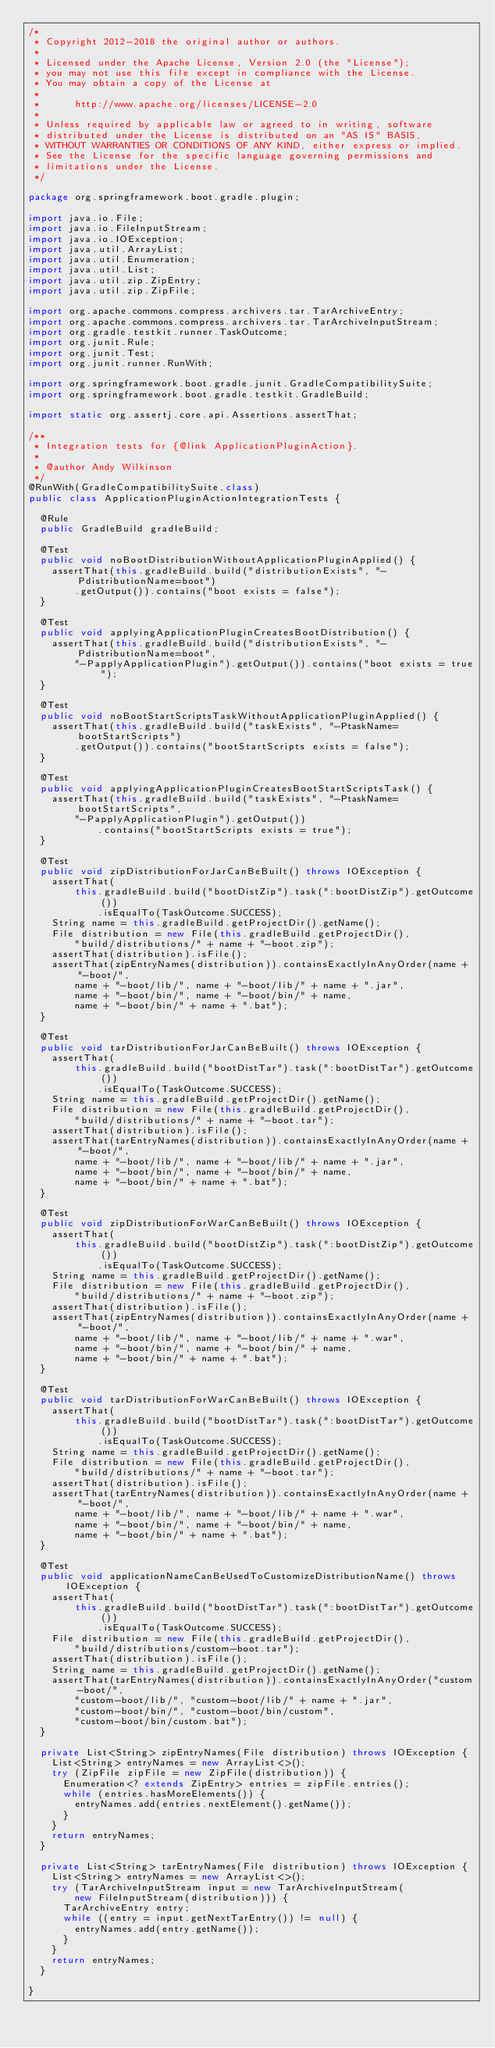Convert code to text. <code><loc_0><loc_0><loc_500><loc_500><_Java_>/*
 * Copyright 2012-2018 the original author or authors.
 *
 * Licensed under the Apache License, Version 2.0 (the "License");
 * you may not use this file except in compliance with the License.
 * You may obtain a copy of the License at
 *
 *      http://www.apache.org/licenses/LICENSE-2.0
 *
 * Unless required by applicable law or agreed to in writing, software
 * distributed under the License is distributed on an "AS IS" BASIS,
 * WITHOUT WARRANTIES OR CONDITIONS OF ANY KIND, either express or implied.
 * See the License for the specific language governing permissions and
 * limitations under the License.
 */

package org.springframework.boot.gradle.plugin;

import java.io.File;
import java.io.FileInputStream;
import java.io.IOException;
import java.util.ArrayList;
import java.util.Enumeration;
import java.util.List;
import java.util.zip.ZipEntry;
import java.util.zip.ZipFile;

import org.apache.commons.compress.archivers.tar.TarArchiveEntry;
import org.apache.commons.compress.archivers.tar.TarArchiveInputStream;
import org.gradle.testkit.runner.TaskOutcome;
import org.junit.Rule;
import org.junit.Test;
import org.junit.runner.RunWith;

import org.springframework.boot.gradle.junit.GradleCompatibilitySuite;
import org.springframework.boot.gradle.testkit.GradleBuild;

import static org.assertj.core.api.Assertions.assertThat;

/**
 * Integration tests for {@link ApplicationPluginAction}.
 *
 * @author Andy Wilkinson
 */
@RunWith(GradleCompatibilitySuite.class)
public class ApplicationPluginActionIntegrationTests {

	@Rule
	public GradleBuild gradleBuild;

	@Test
	public void noBootDistributionWithoutApplicationPluginApplied() {
		assertThat(this.gradleBuild.build("distributionExists", "-PdistributionName=boot")
				.getOutput()).contains("boot exists = false");
	}

	@Test
	public void applyingApplicationPluginCreatesBootDistribution() {
		assertThat(this.gradleBuild.build("distributionExists", "-PdistributionName=boot",
				"-PapplyApplicationPlugin").getOutput()).contains("boot exists = true");
	}

	@Test
	public void noBootStartScriptsTaskWithoutApplicationPluginApplied() {
		assertThat(this.gradleBuild.build("taskExists", "-PtaskName=bootStartScripts")
				.getOutput()).contains("bootStartScripts exists = false");
	}

	@Test
	public void applyingApplicationPluginCreatesBootStartScriptsTask() {
		assertThat(this.gradleBuild.build("taskExists", "-PtaskName=bootStartScripts",
				"-PapplyApplicationPlugin").getOutput())
						.contains("bootStartScripts exists = true");
	}

	@Test
	public void zipDistributionForJarCanBeBuilt() throws IOException {
		assertThat(
				this.gradleBuild.build("bootDistZip").task(":bootDistZip").getOutcome())
						.isEqualTo(TaskOutcome.SUCCESS);
		String name = this.gradleBuild.getProjectDir().getName();
		File distribution = new File(this.gradleBuild.getProjectDir(),
				"build/distributions/" + name + "-boot.zip");
		assertThat(distribution).isFile();
		assertThat(zipEntryNames(distribution)).containsExactlyInAnyOrder(name + "-boot/",
				name + "-boot/lib/", name + "-boot/lib/" + name + ".jar",
				name + "-boot/bin/", name + "-boot/bin/" + name,
				name + "-boot/bin/" + name + ".bat");
	}

	@Test
	public void tarDistributionForJarCanBeBuilt() throws IOException {
		assertThat(
				this.gradleBuild.build("bootDistTar").task(":bootDistTar").getOutcome())
						.isEqualTo(TaskOutcome.SUCCESS);
		String name = this.gradleBuild.getProjectDir().getName();
		File distribution = new File(this.gradleBuild.getProjectDir(),
				"build/distributions/" + name + "-boot.tar");
		assertThat(distribution).isFile();
		assertThat(tarEntryNames(distribution)).containsExactlyInAnyOrder(name + "-boot/",
				name + "-boot/lib/", name + "-boot/lib/" + name + ".jar",
				name + "-boot/bin/", name + "-boot/bin/" + name,
				name + "-boot/bin/" + name + ".bat");
	}

	@Test
	public void zipDistributionForWarCanBeBuilt() throws IOException {
		assertThat(
				this.gradleBuild.build("bootDistZip").task(":bootDistZip").getOutcome())
						.isEqualTo(TaskOutcome.SUCCESS);
		String name = this.gradleBuild.getProjectDir().getName();
		File distribution = new File(this.gradleBuild.getProjectDir(),
				"build/distributions/" + name + "-boot.zip");
		assertThat(distribution).isFile();
		assertThat(zipEntryNames(distribution)).containsExactlyInAnyOrder(name + "-boot/",
				name + "-boot/lib/", name + "-boot/lib/" + name + ".war",
				name + "-boot/bin/", name + "-boot/bin/" + name,
				name + "-boot/bin/" + name + ".bat");
	}

	@Test
	public void tarDistributionForWarCanBeBuilt() throws IOException {
		assertThat(
				this.gradleBuild.build("bootDistTar").task(":bootDistTar").getOutcome())
						.isEqualTo(TaskOutcome.SUCCESS);
		String name = this.gradleBuild.getProjectDir().getName();
		File distribution = new File(this.gradleBuild.getProjectDir(),
				"build/distributions/" + name + "-boot.tar");
		assertThat(distribution).isFile();
		assertThat(tarEntryNames(distribution)).containsExactlyInAnyOrder(name + "-boot/",
				name + "-boot/lib/", name + "-boot/lib/" + name + ".war",
				name + "-boot/bin/", name + "-boot/bin/" + name,
				name + "-boot/bin/" + name + ".bat");
	}

	@Test
	public void applicationNameCanBeUsedToCustomizeDistributionName() throws IOException {
		assertThat(
				this.gradleBuild.build("bootDistTar").task(":bootDistTar").getOutcome())
						.isEqualTo(TaskOutcome.SUCCESS);
		File distribution = new File(this.gradleBuild.getProjectDir(),
				"build/distributions/custom-boot.tar");
		assertThat(distribution).isFile();
		String name = this.gradleBuild.getProjectDir().getName();
		assertThat(tarEntryNames(distribution)).containsExactlyInAnyOrder("custom-boot/",
				"custom-boot/lib/", "custom-boot/lib/" + name + ".jar",
				"custom-boot/bin/", "custom-boot/bin/custom",
				"custom-boot/bin/custom.bat");
	}

	private List<String> zipEntryNames(File distribution) throws IOException {
		List<String> entryNames = new ArrayList<>();
		try (ZipFile zipFile = new ZipFile(distribution)) {
			Enumeration<? extends ZipEntry> entries = zipFile.entries();
			while (entries.hasMoreElements()) {
				entryNames.add(entries.nextElement().getName());
			}
		}
		return entryNames;
	}

	private List<String> tarEntryNames(File distribution) throws IOException {
		List<String> entryNames = new ArrayList<>();
		try (TarArchiveInputStream input = new TarArchiveInputStream(
				new FileInputStream(distribution))) {
			TarArchiveEntry entry;
			while ((entry = input.getNextTarEntry()) != null) {
				entryNames.add(entry.getName());
			}
		}
		return entryNames;
	}

}
</code> 